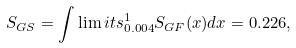Convert formula to latex. <formula><loc_0><loc_0><loc_500><loc_500>S _ { G S } = \int \lim i t s _ { 0 . 0 0 4 } ^ { 1 } S _ { G F } ( x ) d x = 0 . 2 2 6 ,</formula> 